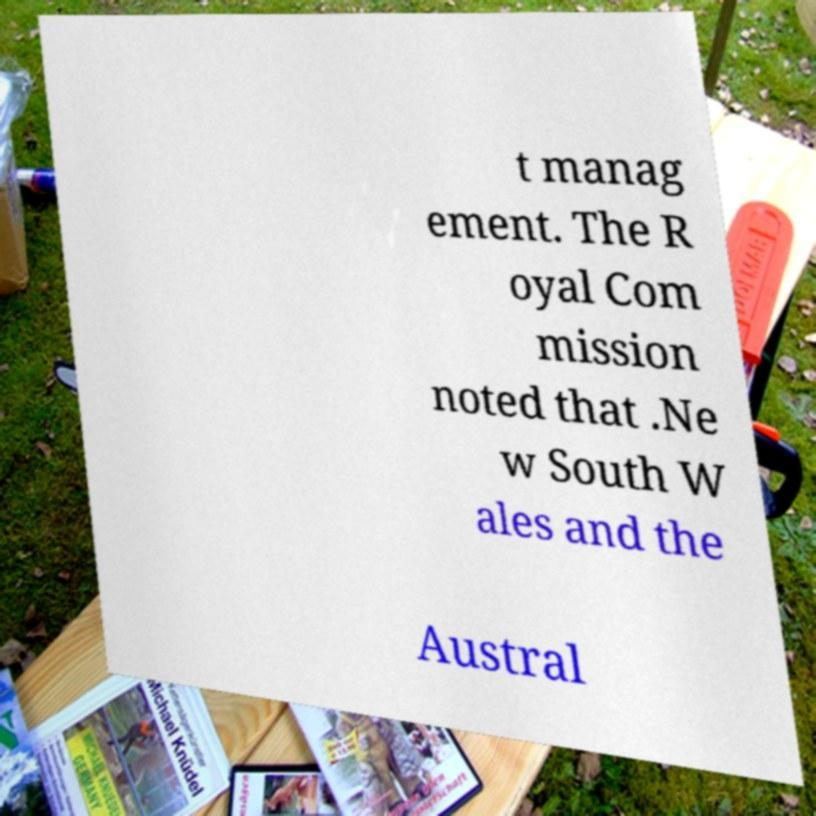What messages or text are displayed in this image? I need them in a readable, typed format. t manag ement. The R oyal Com mission noted that .Ne w South W ales and the Austral 